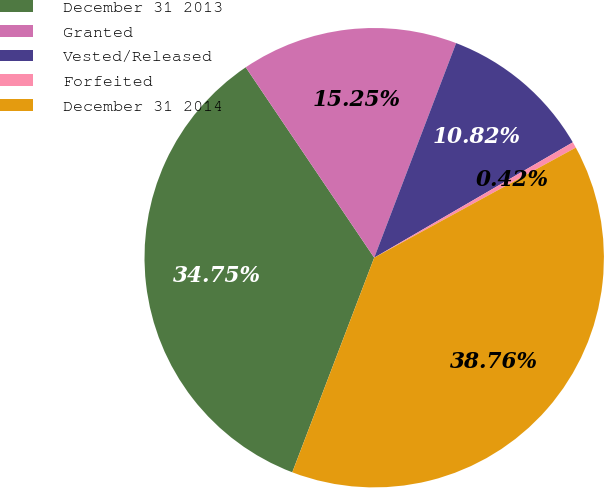<chart> <loc_0><loc_0><loc_500><loc_500><pie_chart><fcel>December 31 2013<fcel>Granted<fcel>Vested/Released<fcel>Forfeited<fcel>December 31 2014<nl><fcel>34.75%<fcel>15.25%<fcel>10.82%<fcel>0.42%<fcel>38.76%<nl></chart> 